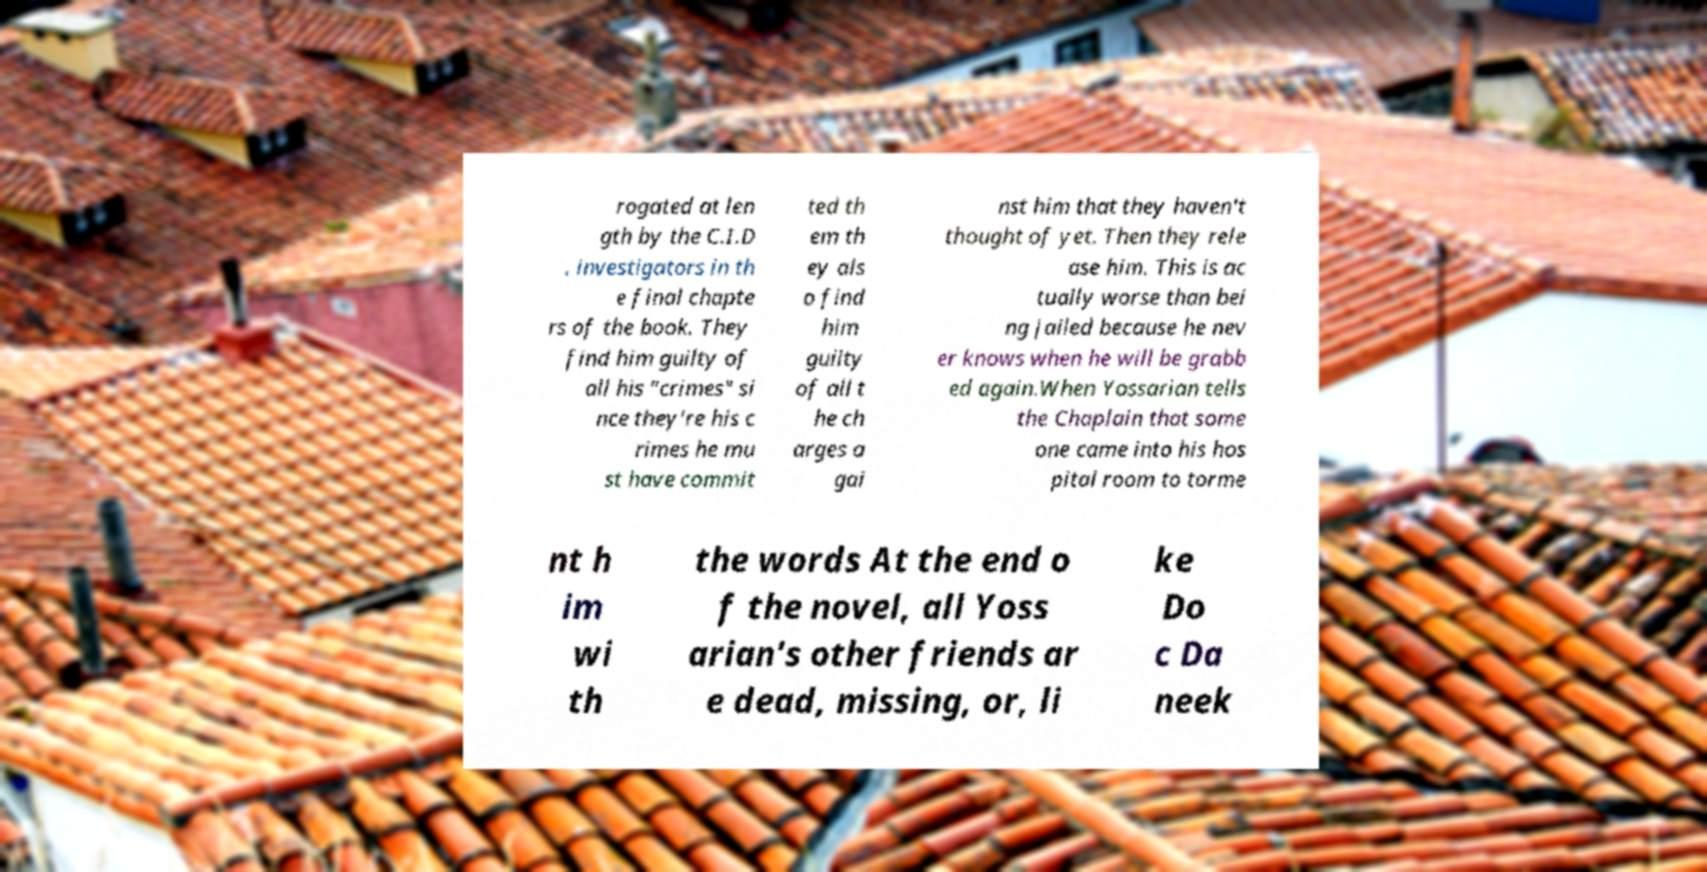There's text embedded in this image that I need extracted. Can you transcribe it verbatim? rogated at len gth by the C.I.D . investigators in th e final chapte rs of the book. They find him guilty of all his "crimes" si nce they're his c rimes he mu st have commit ted th em th ey als o find him guilty of all t he ch arges a gai nst him that they haven't thought of yet. Then they rele ase him. This is ac tually worse than bei ng jailed because he nev er knows when he will be grabb ed again.When Yossarian tells the Chaplain that some one came into his hos pital room to torme nt h im wi th the words At the end o f the novel, all Yoss arian's other friends ar e dead, missing, or, li ke Do c Da neek 